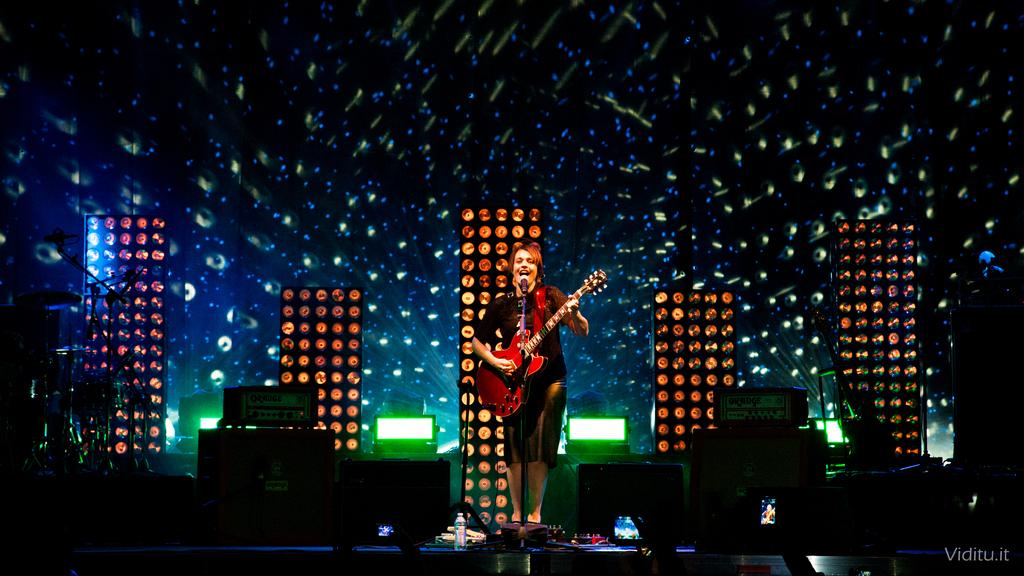What is the person in the image doing? The person is playing a guitar. What is the person wearing in the image? The person is wearing a black dress. What object is in front of the person? There is a microphone in front of the person. What can be seen in the background of the image? There are lights visible in the background of the image. What type of oven is being used to cook the person's idea in the image? There is no oven or cooking of ideas present in the image; it features a person playing a guitar with a microphone in front of them. 